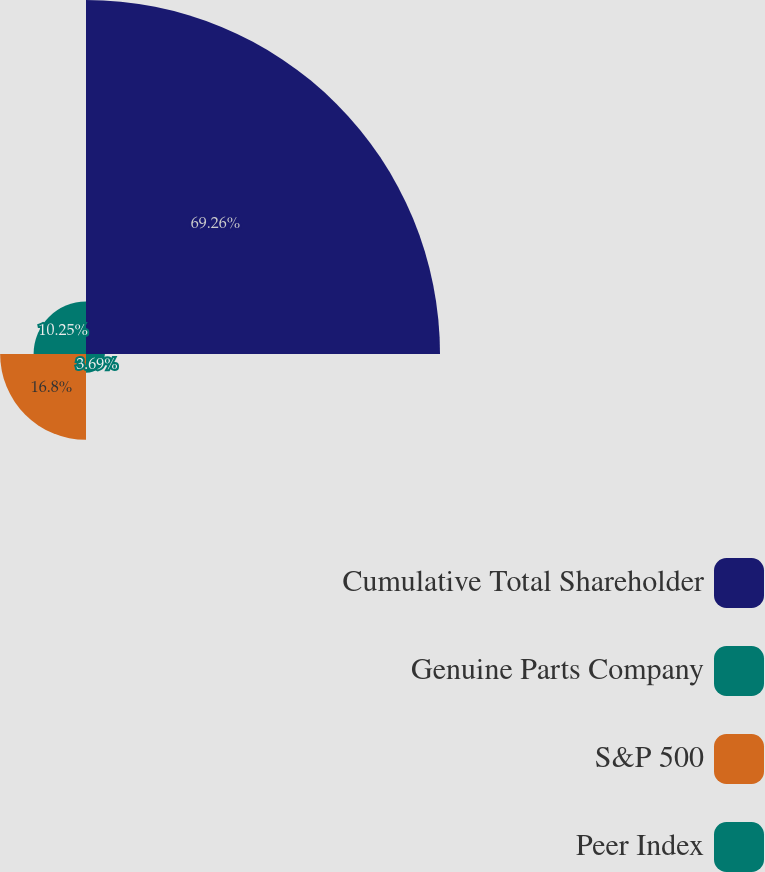<chart> <loc_0><loc_0><loc_500><loc_500><pie_chart><fcel>Cumulative Total Shareholder<fcel>Genuine Parts Company<fcel>S&P 500<fcel>Peer Index<nl><fcel>69.26%<fcel>3.69%<fcel>16.8%<fcel>10.25%<nl></chart> 